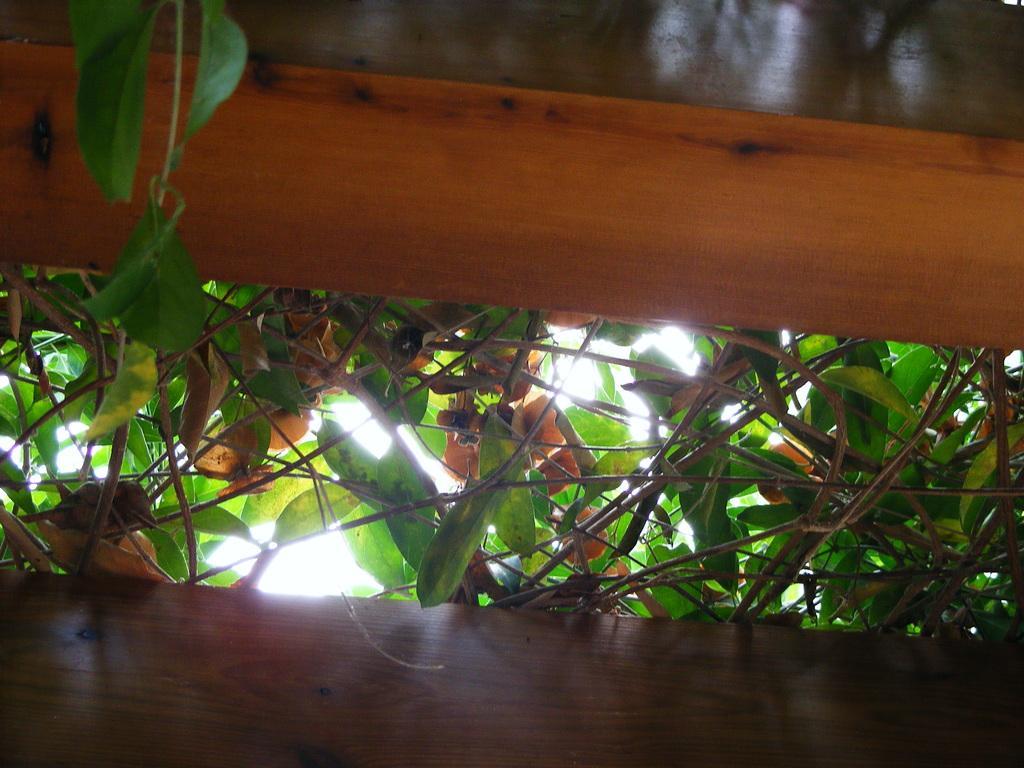Describe this image in one or two sentences. In this image there are plants and wooden poles. 